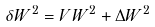Convert formula to latex. <formula><loc_0><loc_0><loc_500><loc_500>\delta W ^ { 2 } = V W ^ { 2 } + \Delta W ^ { 2 }</formula> 